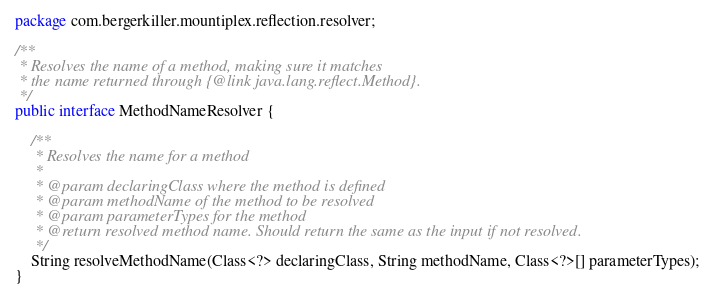<code> <loc_0><loc_0><loc_500><loc_500><_Java_>package com.bergerkiller.mountiplex.reflection.resolver;

/**
 * Resolves the name of a method, making sure it matches
 * the name returned through {@link java.lang.reflect.Method}.
 */
public interface MethodNameResolver {

    /**
     * Resolves the name for a method
     * 
     * @param declaringClass where the method is defined
     * @param methodName of the method to be resolved
     * @param parameterTypes for the method
     * @return resolved method name. Should return the same as the input if not resolved.
     */
    String resolveMethodName(Class<?> declaringClass, String methodName, Class<?>[] parameterTypes);
}
</code> 